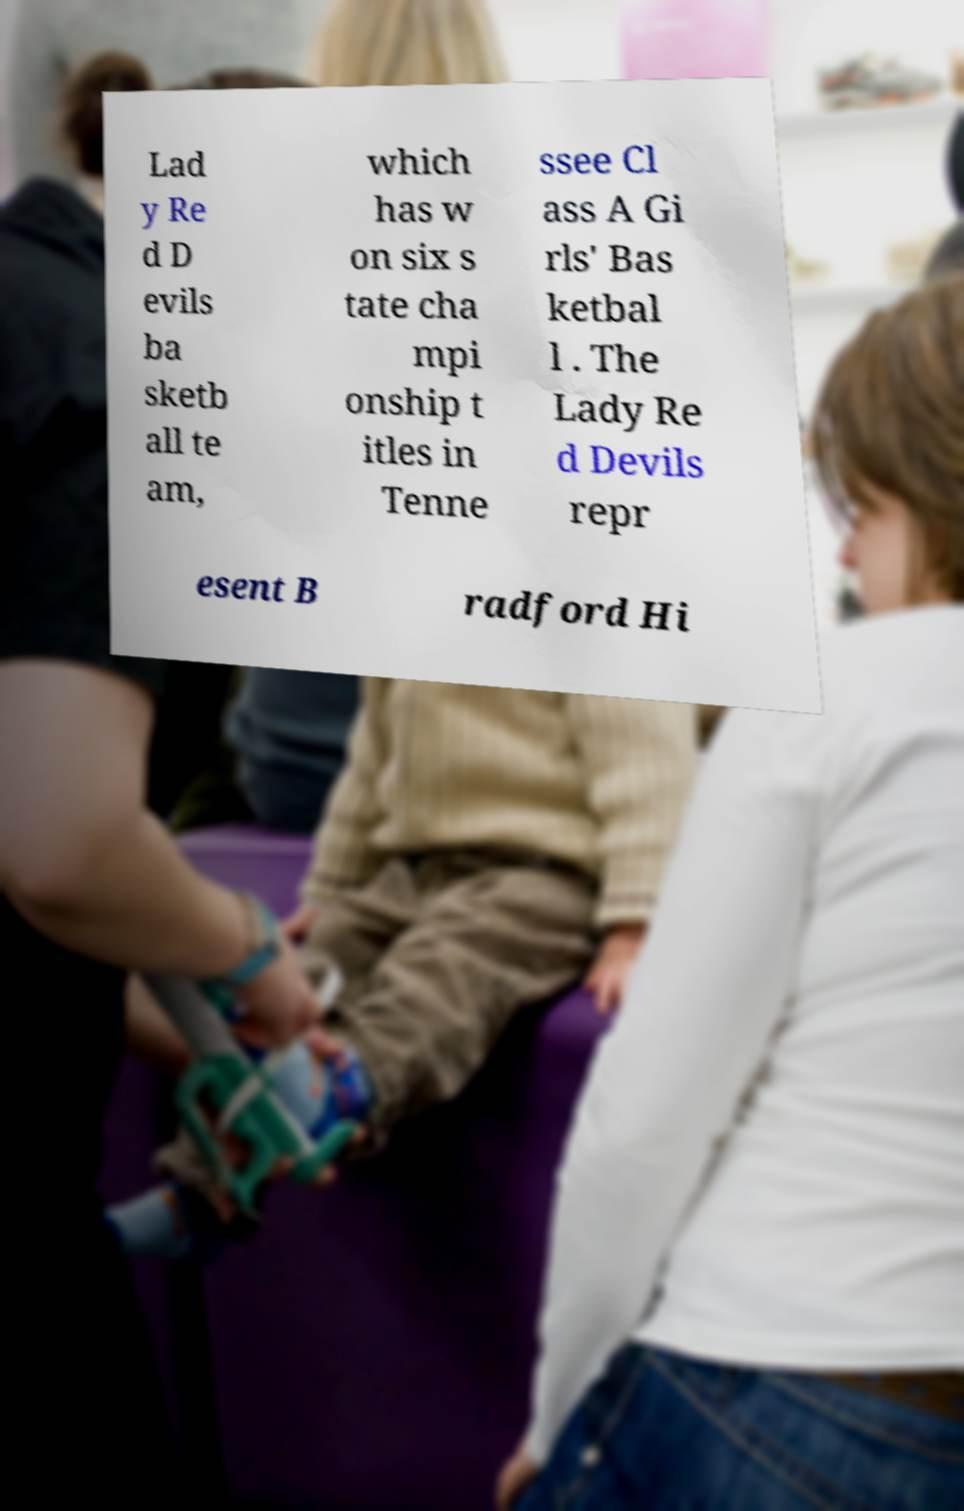I need the written content from this picture converted into text. Can you do that? Lad y Re d D evils ba sketb all te am, which has w on six s tate cha mpi onship t itles in Tenne ssee Cl ass A Gi rls' Bas ketbal l . The Lady Re d Devils repr esent B radford Hi 